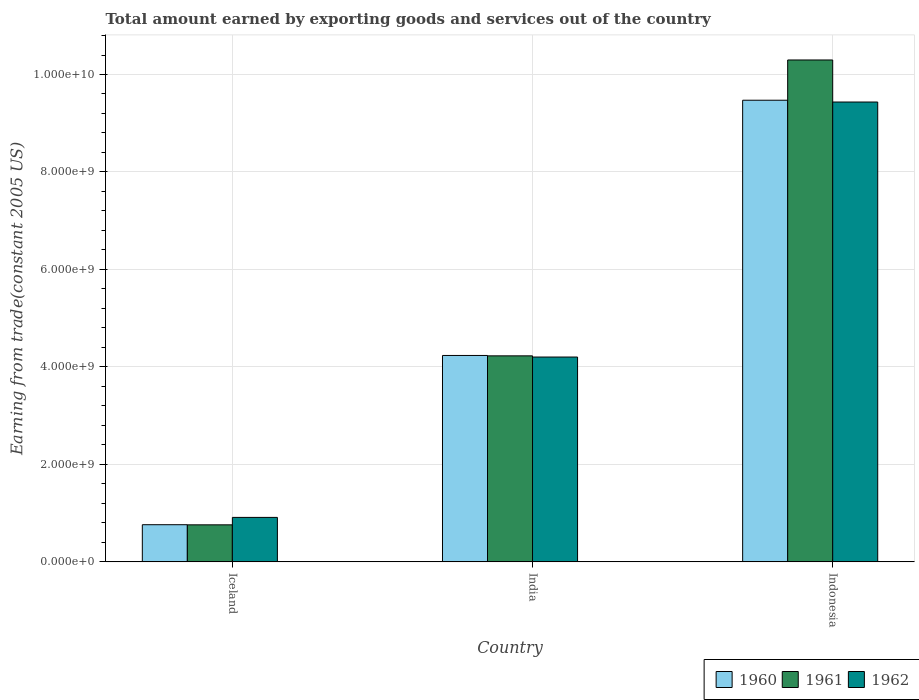Are the number of bars on each tick of the X-axis equal?
Offer a very short reply. Yes. How many bars are there on the 1st tick from the right?
Your answer should be very brief. 3. What is the label of the 1st group of bars from the left?
Offer a terse response. Iceland. In how many cases, is the number of bars for a given country not equal to the number of legend labels?
Your answer should be very brief. 0. What is the total amount earned by exporting goods and services in 1961 in Indonesia?
Offer a terse response. 1.03e+1. Across all countries, what is the maximum total amount earned by exporting goods and services in 1962?
Make the answer very short. 9.44e+09. Across all countries, what is the minimum total amount earned by exporting goods and services in 1962?
Provide a succinct answer. 9.12e+08. In which country was the total amount earned by exporting goods and services in 1962 maximum?
Ensure brevity in your answer.  Indonesia. What is the total total amount earned by exporting goods and services in 1961 in the graph?
Provide a succinct answer. 1.53e+1. What is the difference between the total amount earned by exporting goods and services in 1961 in India and that in Indonesia?
Your answer should be compact. -6.07e+09. What is the difference between the total amount earned by exporting goods and services in 1961 in Iceland and the total amount earned by exporting goods and services in 1960 in Indonesia?
Your response must be concise. -8.71e+09. What is the average total amount earned by exporting goods and services in 1962 per country?
Your response must be concise. 4.85e+09. What is the difference between the total amount earned by exporting goods and services of/in 1962 and total amount earned by exporting goods and services of/in 1960 in Indonesia?
Provide a short and direct response. -3.67e+07. What is the ratio of the total amount earned by exporting goods and services in 1961 in India to that in Indonesia?
Ensure brevity in your answer.  0.41. Is the total amount earned by exporting goods and services in 1961 in Iceland less than that in India?
Give a very brief answer. Yes. What is the difference between the highest and the second highest total amount earned by exporting goods and services in 1960?
Your response must be concise. 5.24e+09. What is the difference between the highest and the lowest total amount earned by exporting goods and services in 1962?
Ensure brevity in your answer.  8.52e+09. In how many countries, is the total amount earned by exporting goods and services in 1960 greater than the average total amount earned by exporting goods and services in 1960 taken over all countries?
Your response must be concise. 1. Is the sum of the total amount earned by exporting goods and services in 1960 in India and Indonesia greater than the maximum total amount earned by exporting goods and services in 1961 across all countries?
Make the answer very short. Yes. Is it the case that in every country, the sum of the total amount earned by exporting goods and services in 1962 and total amount earned by exporting goods and services in 1961 is greater than the total amount earned by exporting goods and services in 1960?
Ensure brevity in your answer.  Yes. How many bars are there?
Offer a terse response. 9. Are all the bars in the graph horizontal?
Your response must be concise. No. How many countries are there in the graph?
Your response must be concise. 3. Are the values on the major ticks of Y-axis written in scientific E-notation?
Offer a terse response. Yes. How many legend labels are there?
Your response must be concise. 3. How are the legend labels stacked?
Your answer should be compact. Horizontal. What is the title of the graph?
Give a very brief answer. Total amount earned by exporting goods and services out of the country. Does "1983" appear as one of the legend labels in the graph?
Provide a succinct answer. No. What is the label or title of the X-axis?
Your response must be concise. Country. What is the label or title of the Y-axis?
Provide a short and direct response. Earning from trade(constant 2005 US). What is the Earning from trade(constant 2005 US) in 1960 in Iceland?
Provide a succinct answer. 7.62e+08. What is the Earning from trade(constant 2005 US) in 1961 in Iceland?
Offer a very short reply. 7.60e+08. What is the Earning from trade(constant 2005 US) of 1962 in Iceland?
Offer a terse response. 9.12e+08. What is the Earning from trade(constant 2005 US) in 1960 in India?
Your answer should be compact. 4.24e+09. What is the Earning from trade(constant 2005 US) in 1961 in India?
Your response must be concise. 4.23e+09. What is the Earning from trade(constant 2005 US) in 1962 in India?
Ensure brevity in your answer.  4.20e+09. What is the Earning from trade(constant 2005 US) of 1960 in Indonesia?
Provide a succinct answer. 9.47e+09. What is the Earning from trade(constant 2005 US) in 1961 in Indonesia?
Keep it short and to the point. 1.03e+1. What is the Earning from trade(constant 2005 US) in 1962 in Indonesia?
Your answer should be very brief. 9.44e+09. Across all countries, what is the maximum Earning from trade(constant 2005 US) of 1960?
Offer a very short reply. 9.47e+09. Across all countries, what is the maximum Earning from trade(constant 2005 US) in 1961?
Offer a terse response. 1.03e+1. Across all countries, what is the maximum Earning from trade(constant 2005 US) in 1962?
Keep it short and to the point. 9.44e+09. Across all countries, what is the minimum Earning from trade(constant 2005 US) in 1960?
Offer a terse response. 7.62e+08. Across all countries, what is the minimum Earning from trade(constant 2005 US) in 1961?
Your response must be concise. 7.60e+08. Across all countries, what is the minimum Earning from trade(constant 2005 US) of 1962?
Your answer should be very brief. 9.12e+08. What is the total Earning from trade(constant 2005 US) in 1960 in the graph?
Your response must be concise. 1.45e+1. What is the total Earning from trade(constant 2005 US) of 1961 in the graph?
Give a very brief answer. 1.53e+1. What is the total Earning from trade(constant 2005 US) in 1962 in the graph?
Provide a short and direct response. 1.46e+1. What is the difference between the Earning from trade(constant 2005 US) of 1960 in Iceland and that in India?
Keep it short and to the point. -3.47e+09. What is the difference between the Earning from trade(constant 2005 US) in 1961 in Iceland and that in India?
Your answer should be compact. -3.47e+09. What is the difference between the Earning from trade(constant 2005 US) of 1962 in Iceland and that in India?
Offer a very short reply. -3.29e+09. What is the difference between the Earning from trade(constant 2005 US) in 1960 in Iceland and that in Indonesia?
Give a very brief answer. -8.71e+09. What is the difference between the Earning from trade(constant 2005 US) in 1961 in Iceland and that in Indonesia?
Offer a terse response. -9.54e+09. What is the difference between the Earning from trade(constant 2005 US) in 1962 in Iceland and that in Indonesia?
Your answer should be very brief. -8.52e+09. What is the difference between the Earning from trade(constant 2005 US) in 1960 in India and that in Indonesia?
Give a very brief answer. -5.24e+09. What is the difference between the Earning from trade(constant 2005 US) of 1961 in India and that in Indonesia?
Your answer should be very brief. -6.07e+09. What is the difference between the Earning from trade(constant 2005 US) in 1962 in India and that in Indonesia?
Give a very brief answer. -5.23e+09. What is the difference between the Earning from trade(constant 2005 US) of 1960 in Iceland and the Earning from trade(constant 2005 US) of 1961 in India?
Give a very brief answer. -3.46e+09. What is the difference between the Earning from trade(constant 2005 US) of 1960 in Iceland and the Earning from trade(constant 2005 US) of 1962 in India?
Your answer should be very brief. -3.44e+09. What is the difference between the Earning from trade(constant 2005 US) of 1961 in Iceland and the Earning from trade(constant 2005 US) of 1962 in India?
Keep it short and to the point. -3.44e+09. What is the difference between the Earning from trade(constant 2005 US) in 1960 in Iceland and the Earning from trade(constant 2005 US) in 1961 in Indonesia?
Provide a succinct answer. -9.54e+09. What is the difference between the Earning from trade(constant 2005 US) in 1960 in Iceland and the Earning from trade(constant 2005 US) in 1962 in Indonesia?
Your response must be concise. -8.67e+09. What is the difference between the Earning from trade(constant 2005 US) in 1961 in Iceland and the Earning from trade(constant 2005 US) in 1962 in Indonesia?
Your response must be concise. -8.68e+09. What is the difference between the Earning from trade(constant 2005 US) in 1960 in India and the Earning from trade(constant 2005 US) in 1961 in Indonesia?
Provide a succinct answer. -6.06e+09. What is the difference between the Earning from trade(constant 2005 US) of 1960 in India and the Earning from trade(constant 2005 US) of 1962 in Indonesia?
Your answer should be very brief. -5.20e+09. What is the difference between the Earning from trade(constant 2005 US) in 1961 in India and the Earning from trade(constant 2005 US) in 1962 in Indonesia?
Give a very brief answer. -5.21e+09. What is the average Earning from trade(constant 2005 US) in 1960 per country?
Provide a short and direct response. 4.82e+09. What is the average Earning from trade(constant 2005 US) of 1961 per country?
Keep it short and to the point. 5.10e+09. What is the average Earning from trade(constant 2005 US) in 1962 per country?
Offer a terse response. 4.85e+09. What is the difference between the Earning from trade(constant 2005 US) of 1960 and Earning from trade(constant 2005 US) of 1961 in Iceland?
Make the answer very short. 2.61e+06. What is the difference between the Earning from trade(constant 2005 US) of 1960 and Earning from trade(constant 2005 US) of 1962 in Iceland?
Give a very brief answer. -1.50e+08. What is the difference between the Earning from trade(constant 2005 US) of 1961 and Earning from trade(constant 2005 US) of 1962 in Iceland?
Offer a very short reply. -1.53e+08. What is the difference between the Earning from trade(constant 2005 US) in 1960 and Earning from trade(constant 2005 US) in 1961 in India?
Provide a short and direct response. 7.87e+06. What is the difference between the Earning from trade(constant 2005 US) in 1960 and Earning from trade(constant 2005 US) in 1962 in India?
Make the answer very short. 3.24e+07. What is the difference between the Earning from trade(constant 2005 US) of 1961 and Earning from trade(constant 2005 US) of 1962 in India?
Your answer should be compact. 2.45e+07. What is the difference between the Earning from trade(constant 2005 US) in 1960 and Earning from trade(constant 2005 US) in 1961 in Indonesia?
Offer a terse response. -8.26e+08. What is the difference between the Earning from trade(constant 2005 US) of 1960 and Earning from trade(constant 2005 US) of 1962 in Indonesia?
Offer a terse response. 3.67e+07. What is the difference between the Earning from trade(constant 2005 US) in 1961 and Earning from trade(constant 2005 US) in 1962 in Indonesia?
Your answer should be very brief. 8.63e+08. What is the ratio of the Earning from trade(constant 2005 US) in 1960 in Iceland to that in India?
Make the answer very short. 0.18. What is the ratio of the Earning from trade(constant 2005 US) in 1961 in Iceland to that in India?
Keep it short and to the point. 0.18. What is the ratio of the Earning from trade(constant 2005 US) of 1962 in Iceland to that in India?
Ensure brevity in your answer.  0.22. What is the ratio of the Earning from trade(constant 2005 US) in 1960 in Iceland to that in Indonesia?
Give a very brief answer. 0.08. What is the ratio of the Earning from trade(constant 2005 US) in 1961 in Iceland to that in Indonesia?
Your answer should be compact. 0.07. What is the ratio of the Earning from trade(constant 2005 US) of 1962 in Iceland to that in Indonesia?
Provide a short and direct response. 0.1. What is the ratio of the Earning from trade(constant 2005 US) of 1960 in India to that in Indonesia?
Provide a succinct answer. 0.45. What is the ratio of the Earning from trade(constant 2005 US) of 1961 in India to that in Indonesia?
Make the answer very short. 0.41. What is the ratio of the Earning from trade(constant 2005 US) in 1962 in India to that in Indonesia?
Offer a terse response. 0.45. What is the difference between the highest and the second highest Earning from trade(constant 2005 US) in 1960?
Keep it short and to the point. 5.24e+09. What is the difference between the highest and the second highest Earning from trade(constant 2005 US) of 1961?
Keep it short and to the point. 6.07e+09. What is the difference between the highest and the second highest Earning from trade(constant 2005 US) of 1962?
Provide a short and direct response. 5.23e+09. What is the difference between the highest and the lowest Earning from trade(constant 2005 US) of 1960?
Offer a very short reply. 8.71e+09. What is the difference between the highest and the lowest Earning from trade(constant 2005 US) in 1961?
Ensure brevity in your answer.  9.54e+09. What is the difference between the highest and the lowest Earning from trade(constant 2005 US) in 1962?
Your answer should be very brief. 8.52e+09. 